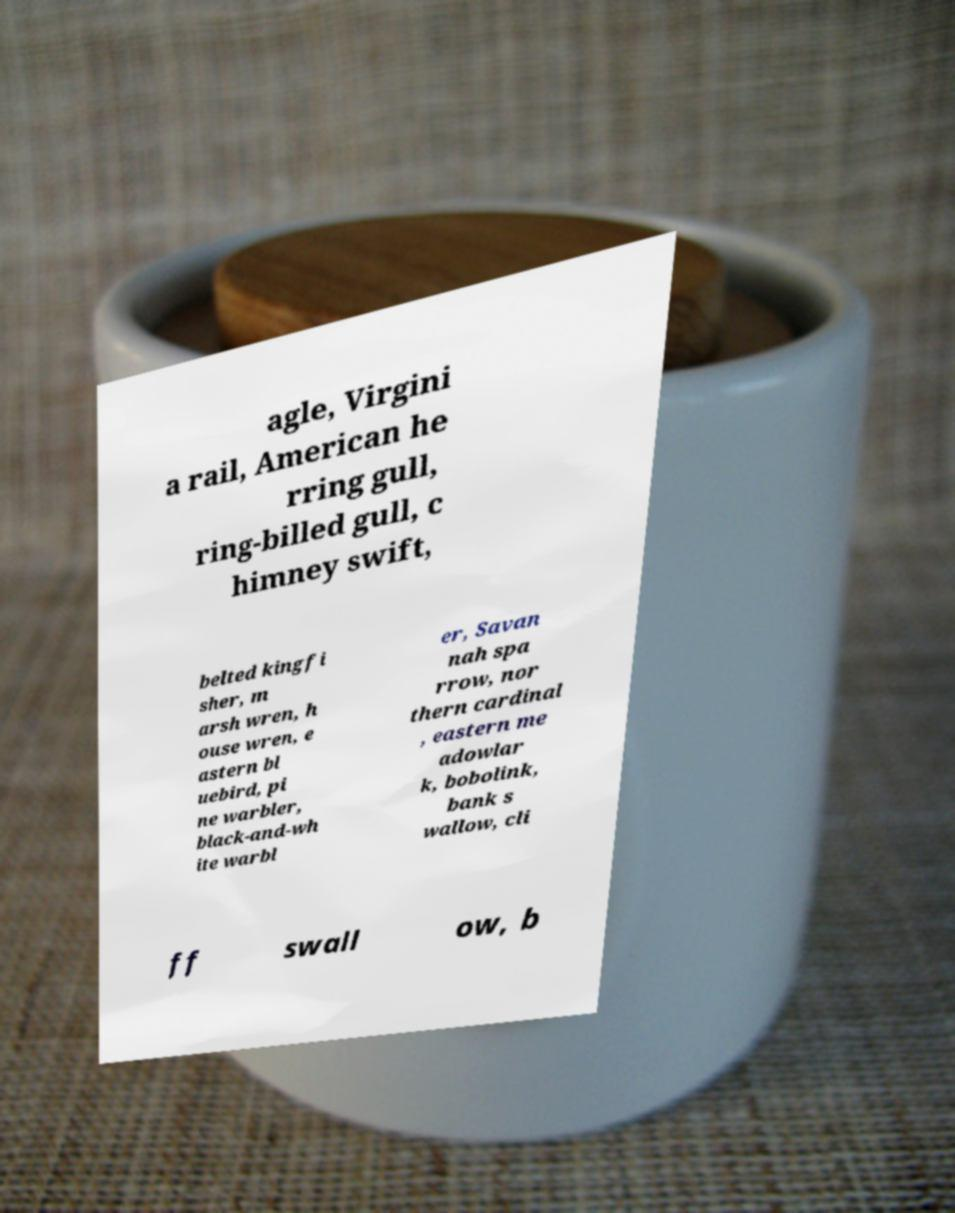Could you extract and type out the text from this image? agle, Virgini a rail, American he rring gull, ring-billed gull, c himney swift, belted kingfi sher, m arsh wren, h ouse wren, e astern bl uebird, pi ne warbler, black-and-wh ite warbl er, Savan nah spa rrow, nor thern cardinal , eastern me adowlar k, bobolink, bank s wallow, cli ff swall ow, b 